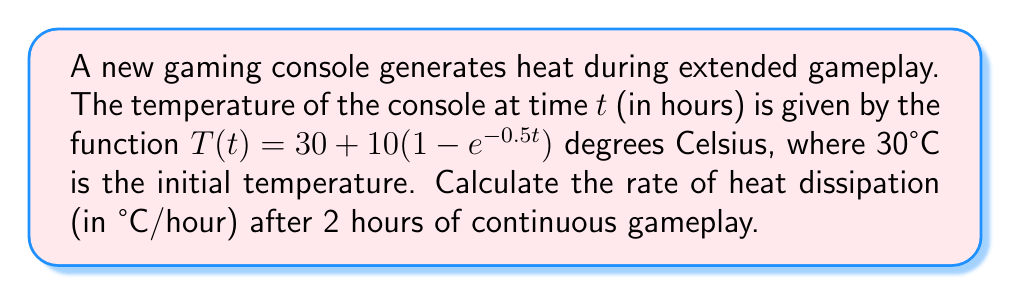Give your solution to this math problem. To determine the rate of heat dissipation, we need to find the derivative of the temperature function with respect to time and evaluate it at t = 2 hours.

1. Given temperature function:
   $$T(t) = 30 + 10(1 - e^{-0.5t})$$

2. Calculate the derivative:
   $$\frac{dT}{dt} = 10 \cdot 0.5 \cdot e^{-0.5t} = 5e^{-0.5t}$$

3. Evaluate the derivative at t = 2 hours:
   $$\frac{dT}{dt}\bigg|_{t=2} = 5e^{-0.5(2)} = 5e^{-1}$$

4. Calculate the final value:
   $$5e^{-1} \approx 1.839$$

The rate of heat dissipation after 2 hours is approximately 1.839°C/hour.
Answer: 1.839°C/hour 